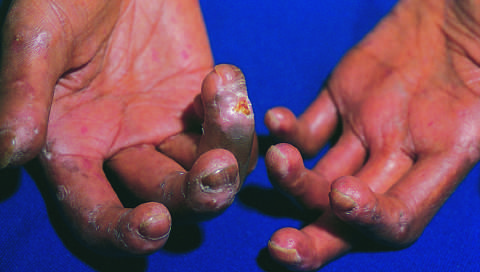has low-power view of a cross section of a skin blister showing the epidermis led to cutaneous ulcerations?
Answer the question using a single word or phrase. No 